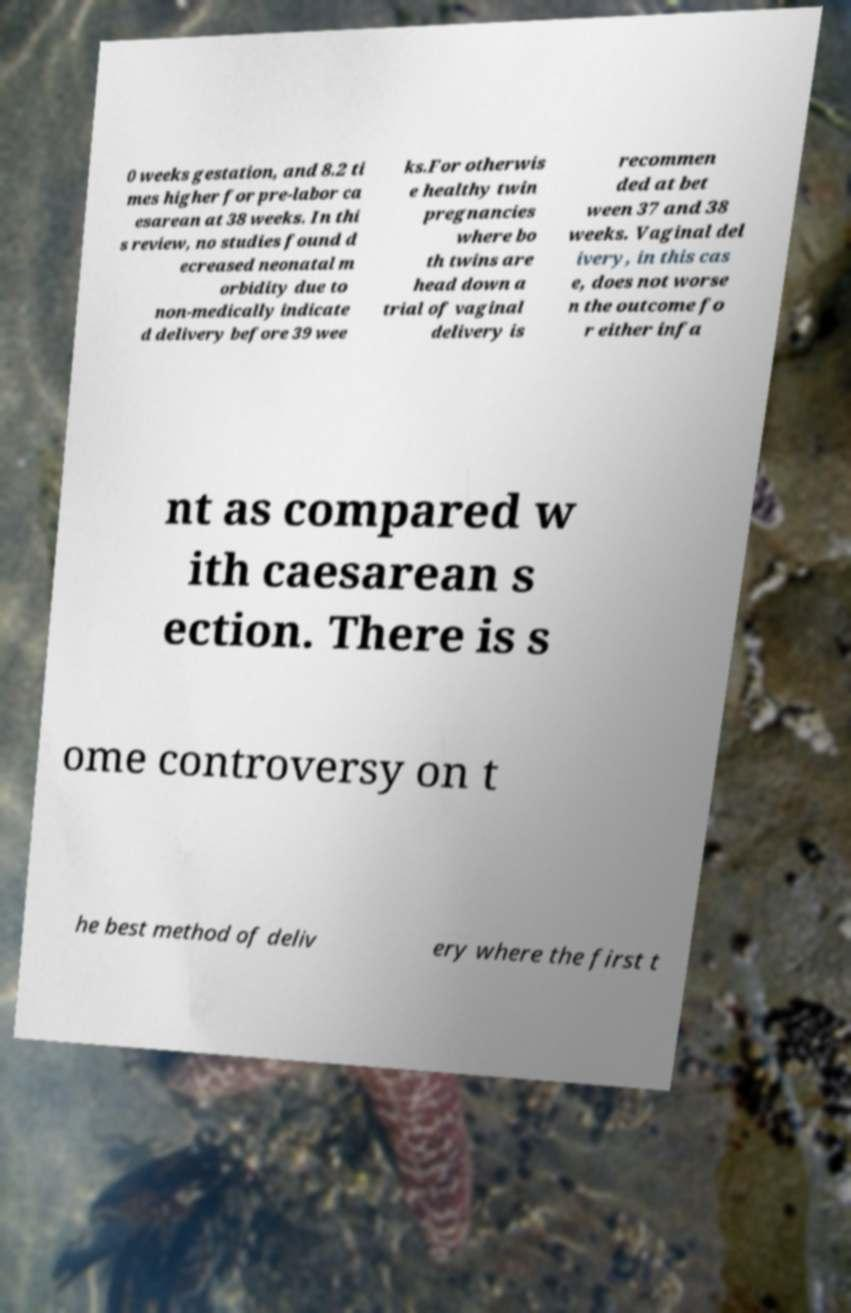There's text embedded in this image that I need extracted. Can you transcribe it verbatim? 0 weeks gestation, and 8.2 ti mes higher for pre-labor ca esarean at 38 weeks. In thi s review, no studies found d ecreased neonatal m orbidity due to non-medically indicate d delivery before 39 wee ks.For otherwis e healthy twin pregnancies where bo th twins are head down a trial of vaginal delivery is recommen ded at bet ween 37 and 38 weeks. Vaginal del ivery, in this cas e, does not worse n the outcome fo r either infa nt as compared w ith caesarean s ection. There is s ome controversy on t he best method of deliv ery where the first t 